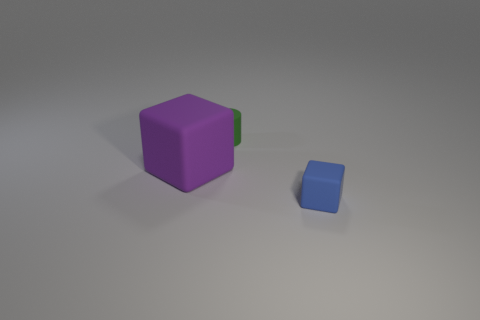What is the size of the other matte thing that is the same shape as the purple thing?
Offer a terse response. Small. Is the green object made of the same material as the large thing?
Provide a succinct answer. Yes. How many objects are either tiny brown metal cylinders or tiny rubber cubes that are to the right of the rubber cylinder?
Make the answer very short. 1. What shape is the small thing that is behind the big purple cube?
Make the answer very short. Cylinder. Do the small thing that is right of the small cylinder and the big matte block have the same color?
Your answer should be compact. No. Do the matte object that is behind the purple matte object and the blue block have the same size?
Your answer should be very brief. Yes. Is there another rubber block that has the same color as the large cube?
Ensure brevity in your answer.  No. Are there any purple matte cubes that are on the left side of the object right of the tiny rubber cylinder?
Your answer should be very brief. Yes. Is there a green thing made of the same material as the purple block?
Provide a short and direct response. Yes. The thing that is in front of the rubber object that is on the left side of the green rubber cylinder is made of what material?
Offer a terse response. Rubber. 